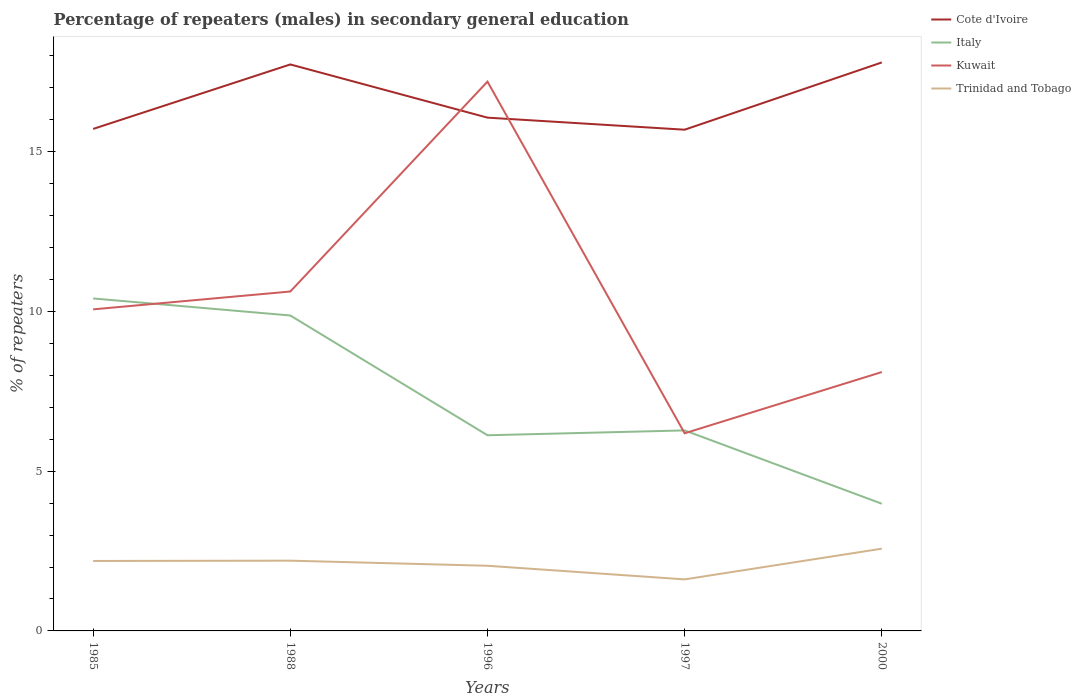Across all years, what is the maximum percentage of male repeaters in Kuwait?
Make the answer very short. 6.19. What is the total percentage of male repeaters in Italy in the graph?
Give a very brief answer. -0.15. What is the difference between the highest and the second highest percentage of male repeaters in Kuwait?
Give a very brief answer. 11.01. What is the difference between the highest and the lowest percentage of male repeaters in Italy?
Ensure brevity in your answer.  2. How many lines are there?
Make the answer very short. 4. How many years are there in the graph?
Provide a short and direct response. 5. What is the difference between two consecutive major ticks on the Y-axis?
Ensure brevity in your answer.  5. Does the graph contain any zero values?
Offer a very short reply. No. Does the graph contain grids?
Offer a terse response. No. What is the title of the graph?
Offer a terse response. Percentage of repeaters (males) in secondary general education. Does "Brunei Darussalam" appear as one of the legend labels in the graph?
Your response must be concise. No. What is the label or title of the X-axis?
Offer a very short reply. Years. What is the label or title of the Y-axis?
Make the answer very short. % of repeaters. What is the % of repeaters of Cote d'Ivoire in 1985?
Offer a terse response. 15.71. What is the % of repeaters in Italy in 1985?
Offer a very short reply. 10.4. What is the % of repeaters of Kuwait in 1985?
Provide a succinct answer. 10.06. What is the % of repeaters in Trinidad and Tobago in 1985?
Offer a very short reply. 2.19. What is the % of repeaters of Cote d'Ivoire in 1988?
Give a very brief answer. 17.73. What is the % of repeaters of Italy in 1988?
Keep it short and to the point. 9.87. What is the % of repeaters of Kuwait in 1988?
Give a very brief answer. 10.62. What is the % of repeaters of Trinidad and Tobago in 1988?
Make the answer very short. 2.2. What is the % of repeaters in Cote d'Ivoire in 1996?
Offer a very short reply. 16.06. What is the % of repeaters of Italy in 1996?
Keep it short and to the point. 6.12. What is the % of repeaters in Kuwait in 1996?
Provide a short and direct response. 17.19. What is the % of repeaters of Trinidad and Tobago in 1996?
Make the answer very short. 2.04. What is the % of repeaters of Cote d'Ivoire in 1997?
Your response must be concise. 15.69. What is the % of repeaters in Italy in 1997?
Offer a very short reply. 6.28. What is the % of repeaters in Kuwait in 1997?
Your answer should be compact. 6.19. What is the % of repeaters of Trinidad and Tobago in 1997?
Ensure brevity in your answer.  1.61. What is the % of repeaters of Cote d'Ivoire in 2000?
Offer a terse response. 17.79. What is the % of repeaters of Italy in 2000?
Provide a short and direct response. 3.98. What is the % of repeaters in Kuwait in 2000?
Your answer should be very brief. 8.1. What is the % of repeaters of Trinidad and Tobago in 2000?
Provide a short and direct response. 2.57. Across all years, what is the maximum % of repeaters of Cote d'Ivoire?
Offer a terse response. 17.79. Across all years, what is the maximum % of repeaters in Italy?
Keep it short and to the point. 10.4. Across all years, what is the maximum % of repeaters of Kuwait?
Make the answer very short. 17.19. Across all years, what is the maximum % of repeaters in Trinidad and Tobago?
Your response must be concise. 2.57. Across all years, what is the minimum % of repeaters in Cote d'Ivoire?
Give a very brief answer. 15.69. Across all years, what is the minimum % of repeaters in Italy?
Provide a short and direct response. 3.98. Across all years, what is the minimum % of repeaters of Kuwait?
Offer a very short reply. 6.19. Across all years, what is the minimum % of repeaters of Trinidad and Tobago?
Provide a short and direct response. 1.61. What is the total % of repeaters of Cote d'Ivoire in the graph?
Keep it short and to the point. 82.98. What is the total % of repeaters of Italy in the graph?
Your response must be concise. 36.65. What is the total % of repeaters of Kuwait in the graph?
Offer a terse response. 52.16. What is the total % of repeaters in Trinidad and Tobago in the graph?
Your answer should be very brief. 10.61. What is the difference between the % of repeaters of Cote d'Ivoire in 1985 and that in 1988?
Provide a short and direct response. -2.02. What is the difference between the % of repeaters in Italy in 1985 and that in 1988?
Keep it short and to the point. 0.53. What is the difference between the % of repeaters in Kuwait in 1985 and that in 1988?
Your response must be concise. -0.56. What is the difference between the % of repeaters of Trinidad and Tobago in 1985 and that in 1988?
Your response must be concise. -0.01. What is the difference between the % of repeaters of Cote d'Ivoire in 1985 and that in 1996?
Give a very brief answer. -0.35. What is the difference between the % of repeaters in Italy in 1985 and that in 1996?
Offer a terse response. 4.28. What is the difference between the % of repeaters of Kuwait in 1985 and that in 1996?
Ensure brevity in your answer.  -7.13. What is the difference between the % of repeaters of Trinidad and Tobago in 1985 and that in 1996?
Your answer should be compact. 0.15. What is the difference between the % of repeaters of Cote d'Ivoire in 1985 and that in 1997?
Provide a succinct answer. 0.02. What is the difference between the % of repeaters in Italy in 1985 and that in 1997?
Keep it short and to the point. 4.13. What is the difference between the % of repeaters in Kuwait in 1985 and that in 1997?
Offer a very short reply. 3.88. What is the difference between the % of repeaters of Trinidad and Tobago in 1985 and that in 1997?
Provide a succinct answer. 0.58. What is the difference between the % of repeaters in Cote d'Ivoire in 1985 and that in 2000?
Ensure brevity in your answer.  -2.08. What is the difference between the % of repeaters of Italy in 1985 and that in 2000?
Keep it short and to the point. 6.42. What is the difference between the % of repeaters in Kuwait in 1985 and that in 2000?
Provide a succinct answer. 1.96. What is the difference between the % of repeaters in Trinidad and Tobago in 1985 and that in 2000?
Make the answer very short. -0.38. What is the difference between the % of repeaters in Cote d'Ivoire in 1988 and that in 1996?
Your response must be concise. 1.67. What is the difference between the % of repeaters of Italy in 1988 and that in 1996?
Give a very brief answer. 3.75. What is the difference between the % of repeaters of Kuwait in 1988 and that in 1996?
Offer a terse response. -6.57. What is the difference between the % of repeaters of Trinidad and Tobago in 1988 and that in 1996?
Provide a short and direct response. 0.16. What is the difference between the % of repeaters of Cote d'Ivoire in 1988 and that in 1997?
Your response must be concise. 2.04. What is the difference between the % of repeaters in Italy in 1988 and that in 1997?
Ensure brevity in your answer.  3.6. What is the difference between the % of repeaters in Kuwait in 1988 and that in 1997?
Your response must be concise. 4.44. What is the difference between the % of repeaters of Trinidad and Tobago in 1988 and that in 1997?
Make the answer very short. 0.59. What is the difference between the % of repeaters of Cote d'Ivoire in 1988 and that in 2000?
Ensure brevity in your answer.  -0.06. What is the difference between the % of repeaters of Italy in 1988 and that in 2000?
Make the answer very short. 5.89. What is the difference between the % of repeaters of Kuwait in 1988 and that in 2000?
Provide a succinct answer. 2.52. What is the difference between the % of repeaters of Trinidad and Tobago in 1988 and that in 2000?
Provide a short and direct response. -0.38. What is the difference between the % of repeaters of Cote d'Ivoire in 1996 and that in 1997?
Make the answer very short. 0.38. What is the difference between the % of repeaters of Italy in 1996 and that in 1997?
Your answer should be very brief. -0.15. What is the difference between the % of repeaters in Kuwait in 1996 and that in 1997?
Your response must be concise. 11.01. What is the difference between the % of repeaters in Trinidad and Tobago in 1996 and that in 1997?
Your answer should be very brief. 0.43. What is the difference between the % of repeaters in Cote d'Ivoire in 1996 and that in 2000?
Provide a succinct answer. -1.73. What is the difference between the % of repeaters of Italy in 1996 and that in 2000?
Provide a short and direct response. 2.14. What is the difference between the % of repeaters of Kuwait in 1996 and that in 2000?
Make the answer very short. 9.09. What is the difference between the % of repeaters of Trinidad and Tobago in 1996 and that in 2000?
Your answer should be very brief. -0.53. What is the difference between the % of repeaters in Cote d'Ivoire in 1997 and that in 2000?
Provide a succinct answer. -2.11. What is the difference between the % of repeaters in Italy in 1997 and that in 2000?
Give a very brief answer. 2.29. What is the difference between the % of repeaters in Kuwait in 1997 and that in 2000?
Give a very brief answer. -1.92. What is the difference between the % of repeaters of Trinidad and Tobago in 1997 and that in 2000?
Make the answer very short. -0.96. What is the difference between the % of repeaters in Cote d'Ivoire in 1985 and the % of repeaters in Italy in 1988?
Your answer should be very brief. 5.84. What is the difference between the % of repeaters in Cote d'Ivoire in 1985 and the % of repeaters in Kuwait in 1988?
Offer a terse response. 5.09. What is the difference between the % of repeaters of Cote d'Ivoire in 1985 and the % of repeaters of Trinidad and Tobago in 1988?
Offer a very short reply. 13.51. What is the difference between the % of repeaters of Italy in 1985 and the % of repeaters of Kuwait in 1988?
Your answer should be compact. -0.22. What is the difference between the % of repeaters of Italy in 1985 and the % of repeaters of Trinidad and Tobago in 1988?
Your answer should be very brief. 8.21. What is the difference between the % of repeaters of Kuwait in 1985 and the % of repeaters of Trinidad and Tobago in 1988?
Give a very brief answer. 7.86. What is the difference between the % of repeaters of Cote d'Ivoire in 1985 and the % of repeaters of Italy in 1996?
Offer a terse response. 9.59. What is the difference between the % of repeaters of Cote d'Ivoire in 1985 and the % of repeaters of Kuwait in 1996?
Your answer should be compact. -1.48. What is the difference between the % of repeaters of Cote d'Ivoire in 1985 and the % of repeaters of Trinidad and Tobago in 1996?
Provide a succinct answer. 13.67. What is the difference between the % of repeaters of Italy in 1985 and the % of repeaters of Kuwait in 1996?
Keep it short and to the point. -6.79. What is the difference between the % of repeaters of Italy in 1985 and the % of repeaters of Trinidad and Tobago in 1996?
Your response must be concise. 8.37. What is the difference between the % of repeaters in Kuwait in 1985 and the % of repeaters in Trinidad and Tobago in 1996?
Give a very brief answer. 8.02. What is the difference between the % of repeaters of Cote d'Ivoire in 1985 and the % of repeaters of Italy in 1997?
Your response must be concise. 9.43. What is the difference between the % of repeaters in Cote d'Ivoire in 1985 and the % of repeaters in Kuwait in 1997?
Your answer should be very brief. 9.52. What is the difference between the % of repeaters in Cote d'Ivoire in 1985 and the % of repeaters in Trinidad and Tobago in 1997?
Your response must be concise. 14.1. What is the difference between the % of repeaters in Italy in 1985 and the % of repeaters in Kuwait in 1997?
Give a very brief answer. 4.22. What is the difference between the % of repeaters in Italy in 1985 and the % of repeaters in Trinidad and Tobago in 1997?
Provide a succinct answer. 8.79. What is the difference between the % of repeaters in Kuwait in 1985 and the % of repeaters in Trinidad and Tobago in 1997?
Provide a succinct answer. 8.45. What is the difference between the % of repeaters in Cote d'Ivoire in 1985 and the % of repeaters in Italy in 2000?
Give a very brief answer. 11.73. What is the difference between the % of repeaters of Cote d'Ivoire in 1985 and the % of repeaters of Kuwait in 2000?
Your answer should be compact. 7.61. What is the difference between the % of repeaters of Cote d'Ivoire in 1985 and the % of repeaters of Trinidad and Tobago in 2000?
Your answer should be very brief. 13.14. What is the difference between the % of repeaters in Italy in 1985 and the % of repeaters in Kuwait in 2000?
Your response must be concise. 2.3. What is the difference between the % of repeaters in Italy in 1985 and the % of repeaters in Trinidad and Tobago in 2000?
Offer a terse response. 7.83. What is the difference between the % of repeaters of Kuwait in 1985 and the % of repeaters of Trinidad and Tobago in 2000?
Give a very brief answer. 7.49. What is the difference between the % of repeaters in Cote d'Ivoire in 1988 and the % of repeaters in Italy in 1996?
Ensure brevity in your answer.  11.6. What is the difference between the % of repeaters in Cote d'Ivoire in 1988 and the % of repeaters in Kuwait in 1996?
Offer a terse response. 0.54. What is the difference between the % of repeaters in Cote d'Ivoire in 1988 and the % of repeaters in Trinidad and Tobago in 1996?
Keep it short and to the point. 15.69. What is the difference between the % of repeaters of Italy in 1988 and the % of repeaters of Kuwait in 1996?
Provide a short and direct response. -7.32. What is the difference between the % of repeaters of Italy in 1988 and the % of repeaters of Trinidad and Tobago in 1996?
Provide a short and direct response. 7.83. What is the difference between the % of repeaters of Kuwait in 1988 and the % of repeaters of Trinidad and Tobago in 1996?
Offer a terse response. 8.58. What is the difference between the % of repeaters of Cote d'Ivoire in 1988 and the % of repeaters of Italy in 1997?
Your response must be concise. 11.45. What is the difference between the % of repeaters of Cote d'Ivoire in 1988 and the % of repeaters of Kuwait in 1997?
Your answer should be very brief. 11.54. What is the difference between the % of repeaters in Cote d'Ivoire in 1988 and the % of repeaters in Trinidad and Tobago in 1997?
Provide a short and direct response. 16.12. What is the difference between the % of repeaters of Italy in 1988 and the % of repeaters of Kuwait in 1997?
Keep it short and to the point. 3.69. What is the difference between the % of repeaters of Italy in 1988 and the % of repeaters of Trinidad and Tobago in 1997?
Offer a very short reply. 8.26. What is the difference between the % of repeaters in Kuwait in 1988 and the % of repeaters in Trinidad and Tobago in 1997?
Provide a short and direct response. 9.01. What is the difference between the % of repeaters of Cote d'Ivoire in 1988 and the % of repeaters of Italy in 2000?
Your answer should be compact. 13.75. What is the difference between the % of repeaters in Cote d'Ivoire in 1988 and the % of repeaters in Kuwait in 2000?
Offer a very short reply. 9.63. What is the difference between the % of repeaters in Cote d'Ivoire in 1988 and the % of repeaters in Trinidad and Tobago in 2000?
Keep it short and to the point. 15.15. What is the difference between the % of repeaters of Italy in 1988 and the % of repeaters of Kuwait in 2000?
Your answer should be very brief. 1.77. What is the difference between the % of repeaters in Italy in 1988 and the % of repeaters in Trinidad and Tobago in 2000?
Keep it short and to the point. 7.3. What is the difference between the % of repeaters in Kuwait in 1988 and the % of repeaters in Trinidad and Tobago in 2000?
Provide a succinct answer. 8.05. What is the difference between the % of repeaters in Cote d'Ivoire in 1996 and the % of repeaters in Italy in 1997?
Ensure brevity in your answer.  9.79. What is the difference between the % of repeaters of Cote d'Ivoire in 1996 and the % of repeaters of Kuwait in 1997?
Your answer should be very brief. 9.88. What is the difference between the % of repeaters in Cote d'Ivoire in 1996 and the % of repeaters in Trinidad and Tobago in 1997?
Make the answer very short. 14.45. What is the difference between the % of repeaters in Italy in 1996 and the % of repeaters in Kuwait in 1997?
Your answer should be compact. -0.06. What is the difference between the % of repeaters of Italy in 1996 and the % of repeaters of Trinidad and Tobago in 1997?
Ensure brevity in your answer.  4.51. What is the difference between the % of repeaters of Kuwait in 1996 and the % of repeaters of Trinidad and Tobago in 1997?
Give a very brief answer. 15.58. What is the difference between the % of repeaters of Cote d'Ivoire in 1996 and the % of repeaters of Italy in 2000?
Your answer should be compact. 12.08. What is the difference between the % of repeaters of Cote d'Ivoire in 1996 and the % of repeaters of Kuwait in 2000?
Keep it short and to the point. 7.96. What is the difference between the % of repeaters in Cote d'Ivoire in 1996 and the % of repeaters in Trinidad and Tobago in 2000?
Your response must be concise. 13.49. What is the difference between the % of repeaters of Italy in 1996 and the % of repeaters of Kuwait in 2000?
Give a very brief answer. -1.98. What is the difference between the % of repeaters in Italy in 1996 and the % of repeaters in Trinidad and Tobago in 2000?
Keep it short and to the point. 3.55. What is the difference between the % of repeaters in Kuwait in 1996 and the % of repeaters in Trinidad and Tobago in 2000?
Offer a terse response. 14.62. What is the difference between the % of repeaters of Cote d'Ivoire in 1997 and the % of repeaters of Italy in 2000?
Give a very brief answer. 11.71. What is the difference between the % of repeaters of Cote d'Ivoire in 1997 and the % of repeaters of Kuwait in 2000?
Keep it short and to the point. 7.58. What is the difference between the % of repeaters of Cote d'Ivoire in 1997 and the % of repeaters of Trinidad and Tobago in 2000?
Offer a very short reply. 13.11. What is the difference between the % of repeaters in Italy in 1997 and the % of repeaters in Kuwait in 2000?
Keep it short and to the point. -1.83. What is the difference between the % of repeaters in Italy in 1997 and the % of repeaters in Trinidad and Tobago in 2000?
Provide a succinct answer. 3.7. What is the difference between the % of repeaters in Kuwait in 1997 and the % of repeaters in Trinidad and Tobago in 2000?
Your response must be concise. 3.61. What is the average % of repeaters of Cote d'Ivoire per year?
Provide a short and direct response. 16.6. What is the average % of repeaters of Italy per year?
Your answer should be compact. 7.33. What is the average % of repeaters in Kuwait per year?
Ensure brevity in your answer.  10.43. What is the average % of repeaters of Trinidad and Tobago per year?
Your answer should be compact. 2.12. In the year 1985, what is the difference between the % of repeaters of Cote d'Ivoire and % of repeaters of Italy?
Ensure brevity in your answer.  5.31. In the year 1985, what is the difference between the % of repeaters of Cote d'Ivoire and % of repeaters of Kuwait?
Your answer should be very brief. 5.65. In the year 1985, what is the difference between the % of repeaters in Cote d'Ivoire and % of repeaters in Trinidad and Tobago?
Keep it short and to the point. 13.52. In the year 1985, what is the difference between the % of repeaters in Italy and % of repeaters in Kuwait?
Keep it short and to the point. 0.34. In the year 1985, what is the difference between the % of repeaters in Italy and % of repeaters in Trinidad and Tobago?
Offer a very short reply. 8.21. In the year 1985, what is the difference between the % of repeaters in Kuwait and % of repeaters in Trinidad and Tobago?
Your answer should be compact. 7.87. In the year 1988, what is the difference between the % of repeaters of Cote d'Ivoire and % of repeaters of Italy?
Provide a short and direct response. 7.86. In the year 1988, what is the difference between the % of repeaters of Cote d'Ivoire and % of repeaters of Kuwait?
Give a very brief answer. 7.11. In the year 1988, what is the difference between the % of repeaters of Cote d'Ivoire and % of repeaters of Trinidad and Tobago?
Your answer should be very brief. 15.53. In the year 1988, what is the difference between the % of repeaters in Italy and % of repeaters in Kuwait?
Give a very brief answer. -0.75. In the year 1988, what is the difference between the % of repeaters in Italy and % of repeaters in Trinidad and Tobago?
Provide a short and direct response. 7.67. In the year 1988, what is the difference between the % of repeaters of Kuwait and % of repeaters of Trinidad and Tobago?
Give a very brief answer. 8.42. In the year 1996, what is the difference between the % of repeaters of Cote d'Ivoire and % of repeaters of Italy?
Your answer should be compact. 9.94. In the year 1996, what is the difference between the % of repeaters in Cote d'Ivoire and % of repeaters in Kuwait?
Offer a very short reply. -1.13. In the year 1996, what is the difference between the % of repeaters in Cote d'Ivoire and % of repeaters in Trinidad and Tobago?
Make the answer very short. 14.02. In the year 1996, what is the difference between the % of repeaters in Italy and % of repeaters in Kuwait?
Provide a short and direct response. -11.07. In the year 1996, what is the difference between the % of repeaters in Italy and % of repeaters in Trinidad and Tobago?
Your answer should be compact. 4.08. In the year 1996, what is the difference between the % of repeaters of Kuwait and % of repeaters of Trinidad and Tobago?
Offer a terse response. 15.15. In the year 1997, what is the difference between the % of repeaters of Cote d'Ivoire and % of repeaters of Italy?
Your response must be concise. 9.41. In the year 1997, what is the difference between the % of repeaters in Cote d'Ivoire and % of repeaters in Kuwait?
Keep it short and to the point. 9.5. In the year 1997, what is the difference between the % of repeaters of Cote d'Ivoire and % of repeaters of Trinidad and Tobago?
Give a very brief answer. 14.07. In the year 1997, what is the difference between the % of repeaters in Italy and % of repeaters in Kuwait?
Ensure brevity in your answer.  0.09. In the year 1997, what is the difference between the % of repeaters of Italy and % of repeaters of Trinidad and Tobago?
Provide a succinct answer. 4.66. In the year 1997, what is the difference between the % of repeaters of Kuwait and % of repeaters of Trinidad and Tobago?
Provide a short and direct response. 4.57. In the year 2000, what is the difference between the % of repeaters of Cote d'Ivoire and % of repeaters of Italy?
Keep it short and to the point. 13.81. In the year 2000, what is the difference between the % of repeaters of Cote d'Ivoire and % of repeaters of Kuwait?
Offer a very short reply. 9.69. In the year 2000, what is the difference between the % of repeaters in Cote d'Ivoire and % of repeaters in Trinidad and Tobago?
Offer a terse response. 15.22. In the year 2000, what is the difference between the % of repeaters of Italy and % of repeaters of Kuwait?
Make the answer very short. -4.12. In the year 2000, what is the difference between the % of repeaters in Italy and % of repeaters in Trinidad and Tobago?
Your answer should be very brief. 1.41. In the year 2000, what is the difference between the % of repeaters in Kuwait and % of repeaters in Trinidad and Tobago?
Your answer should be compact. 5.53. What is the ratio of the % of repeaters of Cote d'Ivoire in 1985 to that in 1988?
Your answer should be very brief. 0.89. What is the ratio of the % of repeaters in Italy in 1985 to that in 1988?
Offer a terse response. 1.05. What is the ratio of the % of repeaters of Trinidad and Tobago in 1985 to that in 1988?
Ensure brevity in your answer.  1. What is the ratio of the % of repeaters in Italy in 1985 to that in 1996?
Your response must be concise. 1.7. What is the ratio of the % of repeaters of Kuwait in 1985 to that in 1996?
Provide a succinct answer. 0.59. What is the ratio of the % of repeaters in Trinidad and Tobago in 1985 to that in 1996?
Provide a short and direct response. 1.07. What is the ratio of the % of repeaters in Italy in 1985 to that in 1997?
Provide a short and direct response. 1.66. What is the ratio of the % of repeaters of Kuwait in 1985 to that in 1997?
Provide a short and direct response. 1.63. What is the ratio of the % of repeaters in Trinidad and Tobago in 1985 to that in 1997?
Provide a succinct answer. 1.36. What is the ratio of the % of repeaters of Cote d'Ivoire in 1985 to that in 2000?
Offer a terse response. 0.88. What is the ratio of the % of repeaters of Italy in 1985 to that in 2000?
Make the answer very short. 2.61. What is the ratio of the % of repeaters of Kuwait in 1985 to that in 2000?
Provide a short and direct response. 1.24. What is the ratio of the % of repeaters in Trinidad and Tobago in 1985 to that in 2000?
Make the answer very short. 0.85. What is the ratio of the % of repeaters in Cote d'Ivoire in 1988 to that in 1996?
Give a very brief answer. 1.1. What is the ratio of the % of repeaters in Italy in 1988 to that in 1996?
Ensure brevity in your answer.  1.61. What is the ratio of the % of repeaters of Kuwait in 1988 to that in 1996?
Your answer should be compact. 0.62. What is the ratio of the % of repeaters of Trinidad and Tobago in 1988 to that in 1996?
Your response must be concise. 1.08. What is the ratio of the % of repeaters of Cote d'Ivoire in 1988 to that in 1997?
Your answer should be very brief. 1.13. What is the ratio of the % of repeaters of Italy in 1988 to that in 1997?
Your answer should be very brief. 1.57. What is the ratio of the % of repeaters of Kuwait in 1988 to that in 1997?
Keep it short and to the point. 1.72. What is the ratio of the % of repeaters in Trinidad and Tobago in 1988 to that in 1997?
Your answer should be very brief. 1.36. What is the ratio of the % of repeaters of Italy in 1988 to that in 2000?
Keep it short and to the point. 2.48. What is the ratio of the % of repeaters of Kuwait in 1988 to that in 2000?
Your response must be concise. 1.31. What is the ratio of the % of repeaters in Trinidad and Tobago in 1988 to that in 2000?
Make the answer very short. 0.85. What is the ratio of the % of repeaters in Italy in 1996 to that in 1997?
Provide a short and direct response. 0.98. What is the ratio of the % of repeaters in Kuwait in 1996 to that in 1997?
Offer a very short reply. 2.78. What is the ratio of the % of repeaters of Trinidad and Tobago in 1996 to that in 1997?
Offer a terse response. 1.26. What is the ratio of the % of repeaters of Cote d'Ivoire in 1996 to that in 2000?
Offer a very short reply. 0.9. What is the ratio of the % of repeaters in Italy in 1996 to that in 2000?
Offer a terse response. 1.54. What is the ratio of the % of repeaters of Kuwait in 1996 to that in 2000?
Your answer should be compact. 2.12. What is the ratio of the % of repeaters in Trinidad and Tobago in 1996 to that in 2000?
Make the answer very short. 0.79. What is the ratio of the % of repeaters of Cote d'Ivoire in 1997 to that in 2000?
Provide a succinct answer. 0.88. What is the ratio of the % of repeaters of Italy in 1997 to that in 2000?
Ensure brevity in your answer.  1.58. What is the ratio of the % of repeaters of Kuwait in 1997 to that in 2000?
Your response must be concise. 0.76. What is the ratio of the % of repeaters in Trinidad and Tobago in 1997 to that in 2000?
Provide a succinct answer. 0.63. What is the difference between the highest and the second highest % of repeaters in Cote d'Ivoire?
Make the answer very short. 0.06. What is the difference between the highest and the second highest % of repeaters of Italy?
Make the answer very short. 0.53. What is the difference between the highest and the second highest % of repeaters of Kuwait?
Make the answer very short. 6.57. What is the difference between the highest and the second highest % of repeaters of Trinidad and Tobago?
Your answer should be very brief. 0.38. What is the difference between the highest and the lowest % of repeaters of Cote d'Ivoire?
Keep it short and to the point. 2.11. What is the difference between the highest and the lowest % of repeaters of Italy?
Keep it short and to the point. 6.42. What is the difference between the highest and the lowest % of repeaters of Kuwait?
Offer a very short reply. 11.01. What is the difference between the highest and the lowest % of repeaters of Trinidad and Tobago?
Ensure brevity in your answer.  0.96. 